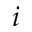Convert formula to latex. <formula><loc_0><loc_0><loc_500><loc_500>i</formula> 